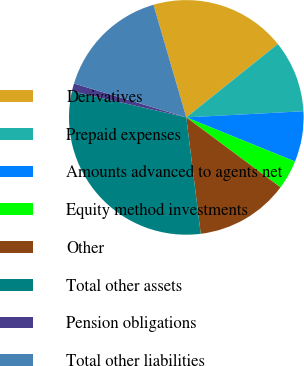<chart> <loc_0><loc_0><loc_500><loc_500><pie_chart><fcel>Derivatives<fcel>Prepaid expenses<fcel>Amounts advanced to agents net<fcel>Equity method investments<fcel>Other<fcel>Total other assets<fcel>Pension obligations<fcel>Total other liabilities<nl><fcel>18.76%<fcel>9.92%<fcel>6.97%<fcel>4.03%<fcel>12.87%<fcel>30.55%<fcel>1.08%<fcel>15.82%<nl></chart> 